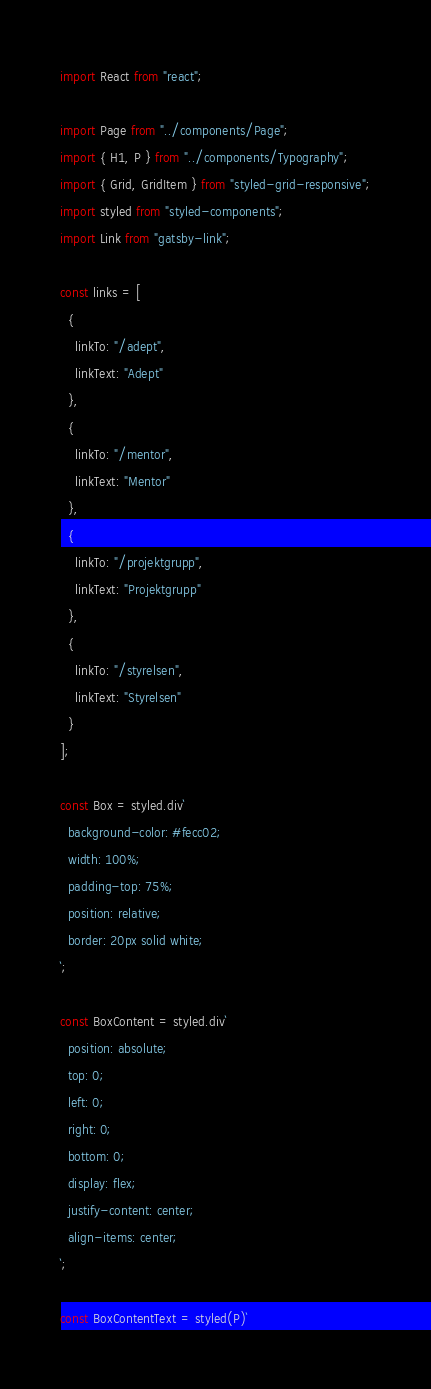Convert code to text. <code><loc_0><loc_0><loc_500><loc_500><_JavaScript_>import React from "react";

import Page from "../components/Page";
import { H1, P } from "../components/Typography";
import { Grid, GridItem } from "styled-grid-responsive";
import styled from "styled-components";
import Link from "gatsby-link";

const links = [
  {
    linkTo: "/adept",
    linkText: "Adept"
  },
  {
    linkTo: "/mentor",
    linkText: "Mentor"
  },
  {
    linkTo: "/projektgrupp",
    linkText: "Projektgrupp"
  },
  {
    linkTo: "/styrelsen",
    linkText: "Styrelsen"
  }
];

const Box = styled.div`
  background-color: #fecc02;
  width: 100%;
  padding-top: 75%;
  position: relative;
  border: 20px solid white;
`;

const BoxContent = styled.div`
  position: absolute;
  top: 0;
  left: 0;
  right: 0;
  bottom: 0;
  display: flex;
  justify-content: center;
  align-items: center;
`;

const BoxContentText = styled(P)`</code> 